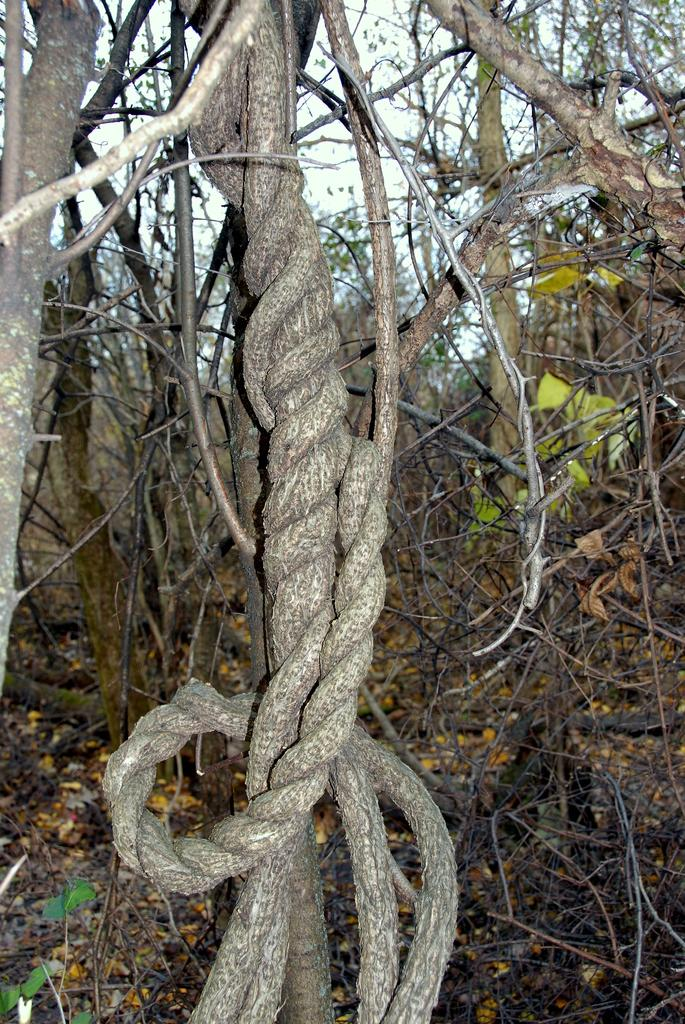What type of vegetation can be seen in the image? There are trees in the image. What is present on the ground beneath the trees? There are dry leaves on the ground in the image. What type of print can be seen on the leaves in the image? There is no print visible on the leaves in the image; the leaves are dry and not printed. 